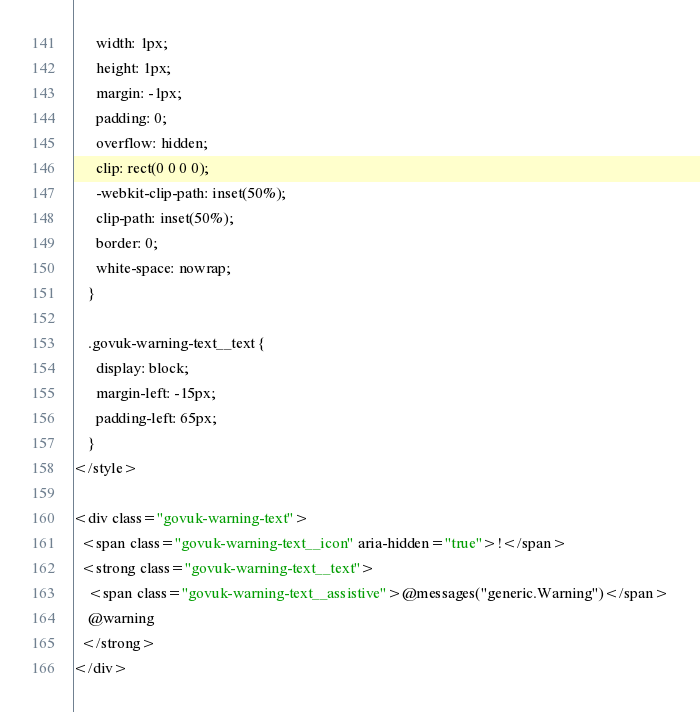<code> <loc_0><loc_0><loc_500><loc_500><_HTML_>      width: 1px;
      height: 1px;
      margin: -1px;
      padding: 0;
      overflow: hidden;
      clip: rect(0 0 0 0);
      -webkit-clip-path: inset(50%);
      clip-path: inset(50%);
      border: 0;
      white-space: nowrap;
    }

    .govuk-warning-text__text {
      display: block;
      margin-left: -15px;
      padding-left: 65px;
    }
</style>

<div class="govuk-warning-text">
  <span class="govuk-warning-text__icon" aria-hidden="true">!</span>
  <strong class="govuk-warning-text__text">
    <span class="govuk-warning-text__assistive">@messages("generic.Warning")</span>
    @warning
  </strong>
</div>
</code> 